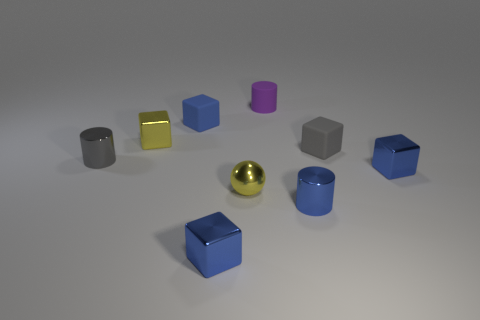Subtract all blue cylinders. How many cylinders are left? 2 Subtract 2 cylinders. How many cylinders are left? 1 Subtract all yellow cubes. How many cubes are left? 4 Add 1 gray cubes. How many objects exist? 10 Subtract all purple cylinders. How many blue blocks are left? 3 Subtract all blocks. How many objects are left? 4 Subtract all green balls. Subtract all purple blocks. How many balls are left? 1 Subtract all gray metal cylinders. Subtract all tiny blue shiny cylinders. How many objects are left? 7 Add 4 small purple things. How many small purple things are left? 5 Add 7 green matte cylinders. How many green matte cylinders exist? 7 